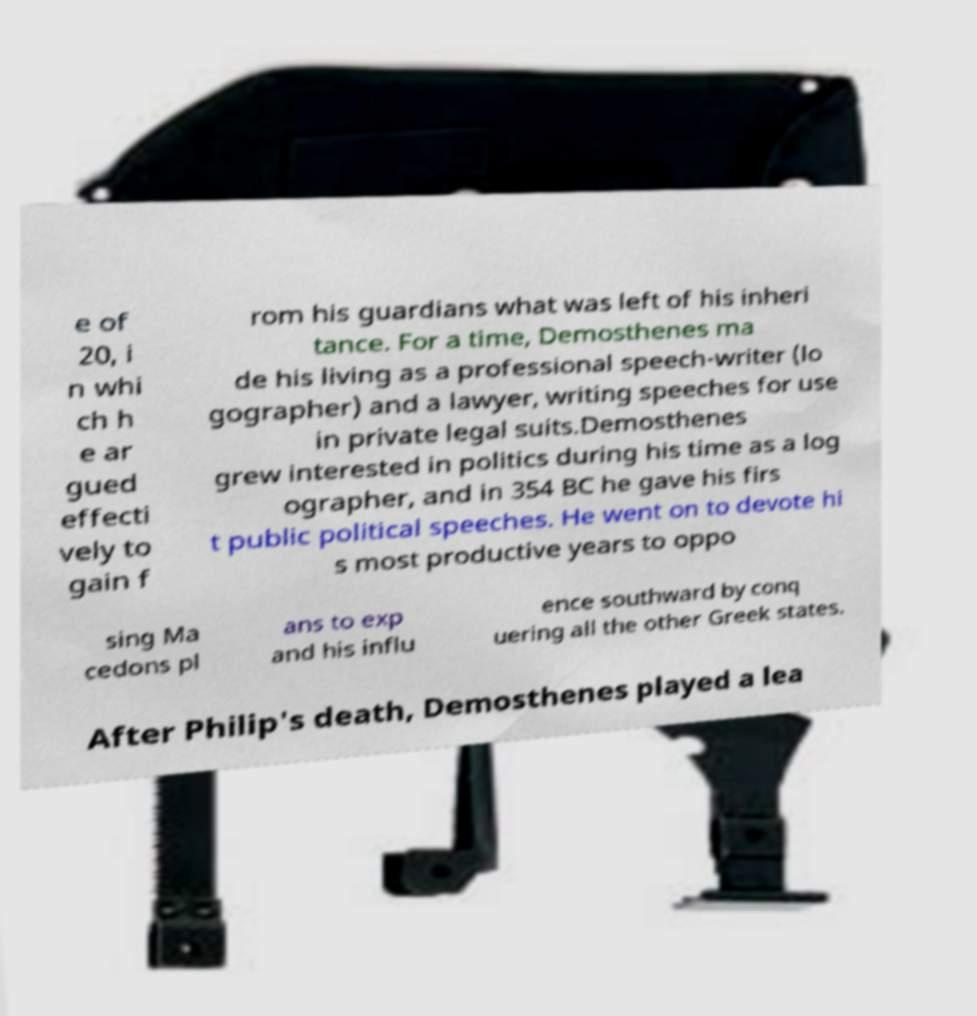Please identify and transcribe the text found in this image. e of 20, i n whi ch h e ar gued effecti vely to gain f rom his guardians what was left of his inheri tance. For a time, Demosthenes ma de his living as a professional speech-writer (lo gographer) and a lawyer, writing speeches for use in private legal suits.Demosthenes grew interested in politics during his time as a log ographer, and in 354 BC he gave his firs t public political speeches. He went on to devote hi s most productive years to oppo sing Ma cedons pl ans to exp and his influ ence southward by conq uering all the other Greek states. After Philip's death, Demosthenes played a lea 